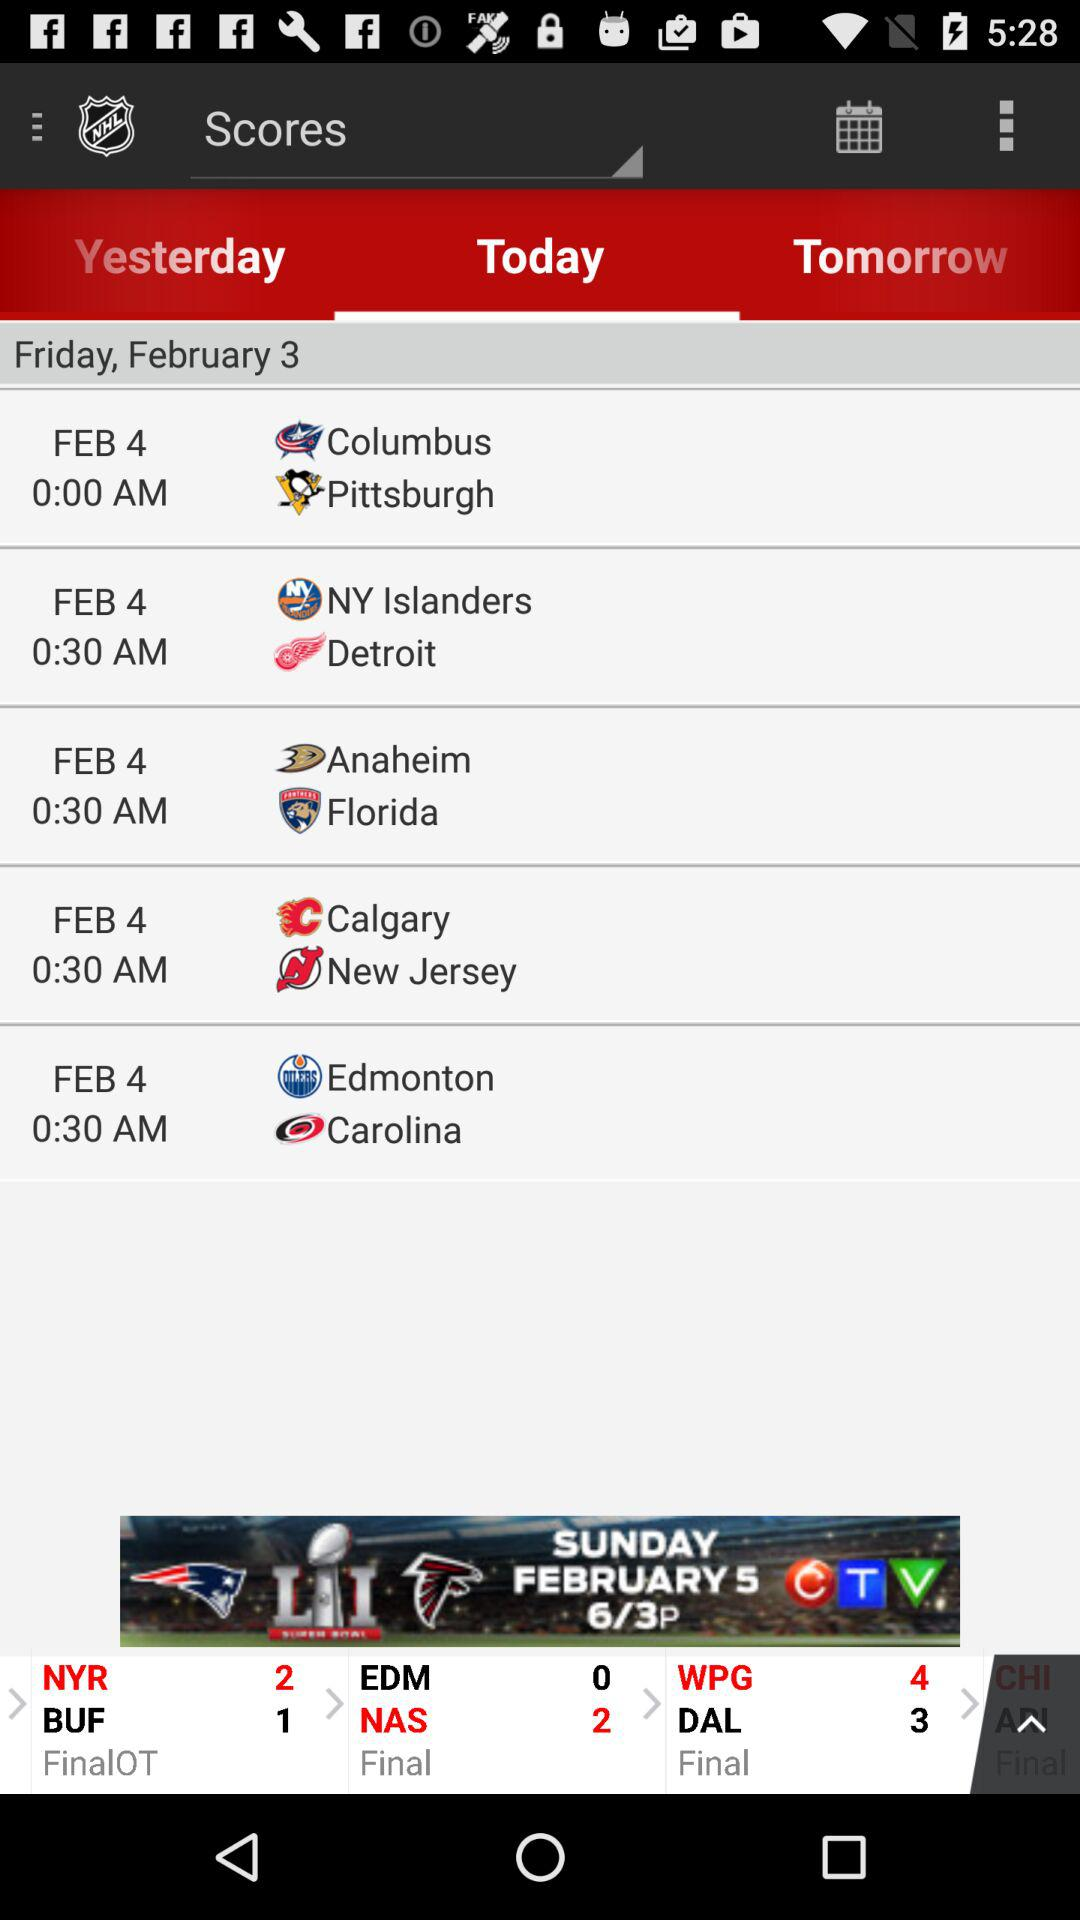What is the date of the match between Calgary and New Jersey? The date of the match between Calgary and New Jersey is February 4. 